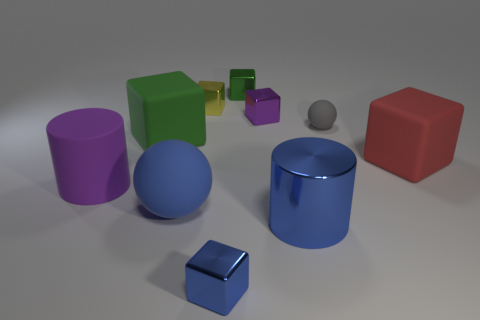Subtract all green shiny blocks. How many blocks are left? 5 Subtract all purple cubes. How many cubes are left? 5 Subtract all tiny blue shiny objects. Subtract all matte objects. How many objects are left? 4 Add 1 small blocks. How many small blocks are left? 5 Add 7 big blue shiny objects. How many big blue shiny objects exist? 8 Subtract 1 red cubes. How many objects are left? 9 Subtract all cylinders. How many objects are left? 8 Subtract 4 blocks. How many blocks are left? 2 Subtract all blue cylinders. Subtract all green spheres. How many cylinders are left? 1 Subtract all cyan blocks. How many purple cylinders are left? 1 